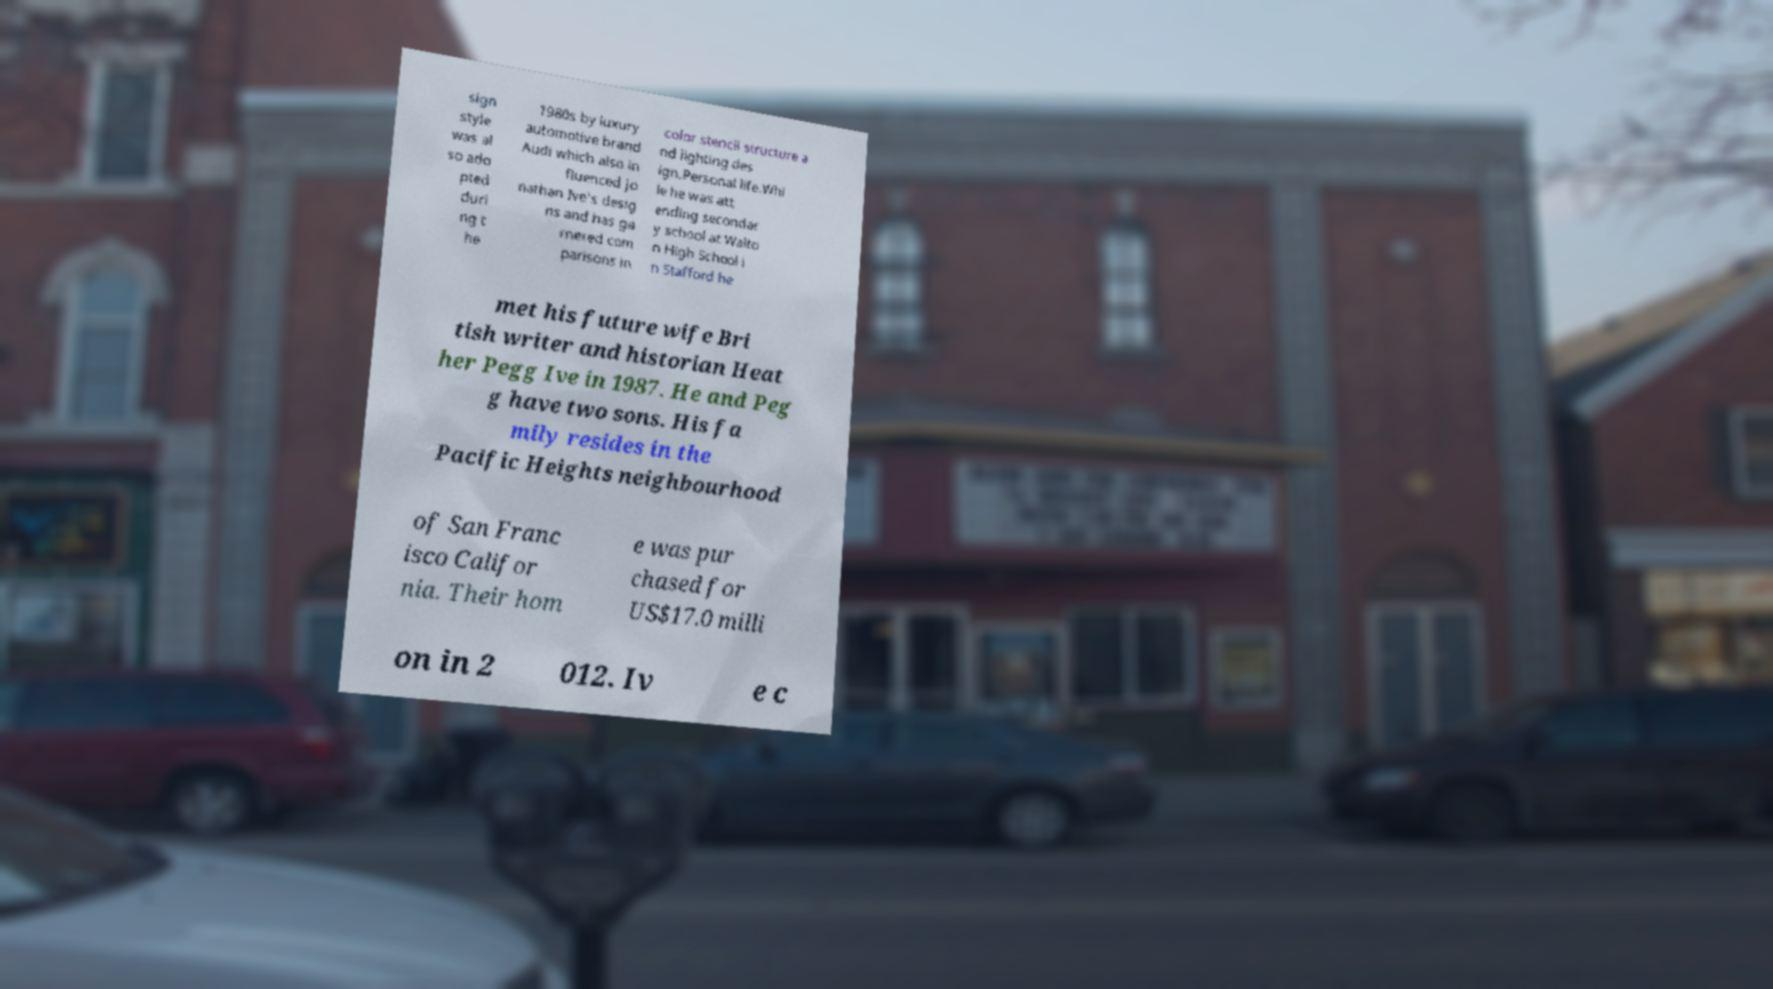Could you assist in decoding the text presented in this image and type it out clearly? sign style was al so ado pted duri ng t he 1980s by luxury automotive brand Audi which also in fluenced Jo nathan Ive's desig ns and has ga rnered com parisons in color stencil structure a nd lighting des ign.Personal life.Whi le he was att ending secondar y school at Walto n High School i n Stafford he met his future wife Bri tish writer and historian Heat her Pegg Ive in 1987. He and Peg g have two sons. His fa mily resides in the Pacific Heights neighbourhood of San Franc isco Califor nia. Their hom e was pur chased for US$17.0 milli on in 2 012. Iv e c 